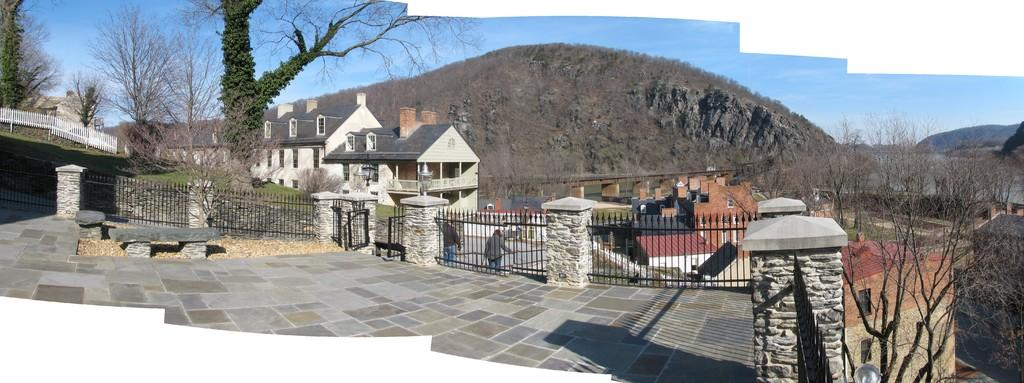What type of natural elements can be seen in the image? There are trees and mountains in the image. What type of man-made structures are present in the image? There are buildings and a gate in the image. What type of architectural features can be seen in the image? There is fencing and windows in the image. What type of lighting is present in the image? There are lights in the image. Are there any people visible in the image? Yes, there are people in the image. What is the color of the sky in the image? The sky is blue in the image. Can you see any shoes on the people in the image? There is no information about shoes in the image, so we cannot determine if any are present. Is there any smoke visible in the image? There is no mention of smoke in the image, so we cannot determine if any is present. 